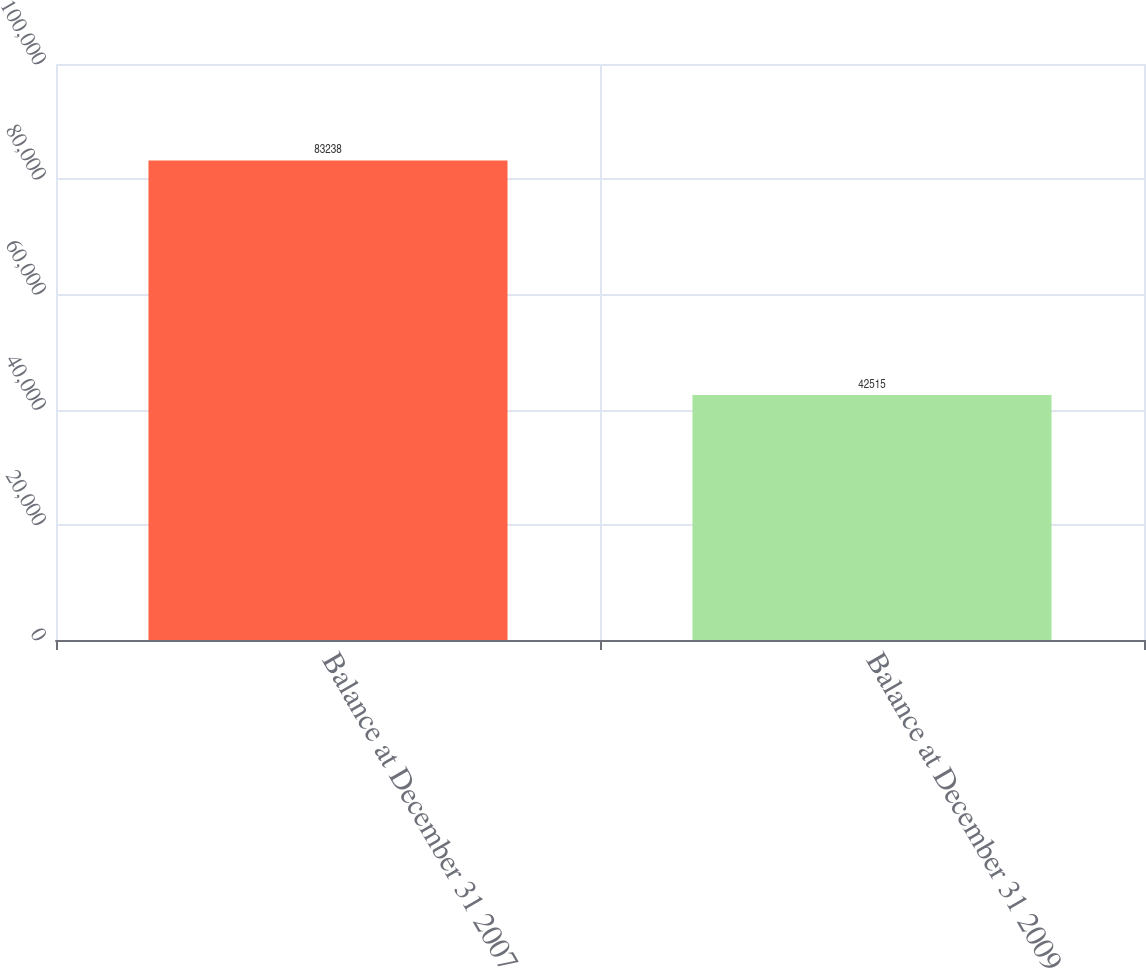<chart> <loc_0><loc_0><loc_500><loc_500><bar_chart><fcel>Balance at December 31 2007<fcel>Balance at December 31 2009<nl><fcel>83238<fcel>42515<nl></chart> 